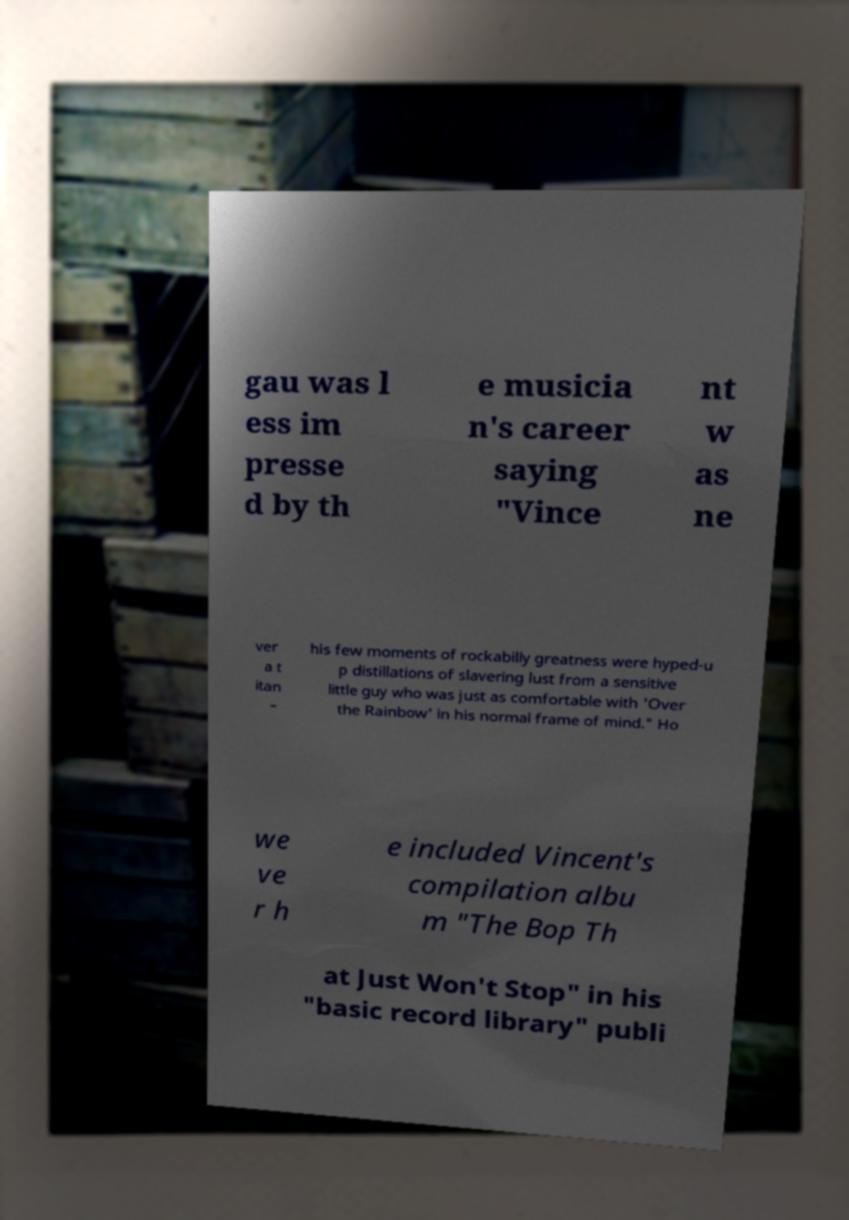There's text embedded in this image that I need extracted. Can you transcribe it verbatim? gau was l ess im presse d by th e musicia n's career saying "Vince nt w as ne ver a t itan – his few moments of rockabilly greatness were hyped-u p distillations of slavering lust from a sensitive little guy who was just as comfortable with 'Over the Rainbow' in his normal frame of mind." Ho we ve r h e included Vincent's compilation albu m "The Bop Th at Just Won't Stop" in his "basic record library" publi 